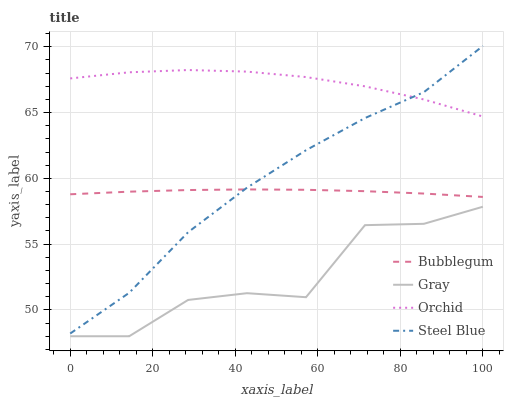Does Gray have the minimum area under the curve?
Answer yes or no. Yes. Does Orchid have the maximum area under the curve?
Answer yes or no. Yes. Does Steel Blue have the minimum area under the curve?
Answer yes or no. No. Does Steel Blue have the maximum area under the curve?
Answer yes or no. No. Is Bubblegum the smoothest?
Answer yes or no. Yes. Is Gray the roughest?
Answer yes or no. Yes. Is Steel Blue the smoothest?
Answer yes or no. No. Is Steel Blue the roughest?
Answer yes or no. No. Does Gray have the lowest value?
Answer yes or no. Yes. Does Steel Blue have the lowest value?
Answer yes or no. No. Does Steel Blue have the highest value?
Answer yes or no. Yes. Does Bubblegum have the highest value?
Answer yes or no. No. Is Gray less than Steel Blue?
Answer yes or no. Yes. Is Orchid greater than Bubblegum?
Answer yes or no. Yes. Does Bubblegum intersect Steel Blue?
Answer yes or no. Yes. Is Bubblegum less than Steel Blue?
Answer yes or no. No. Is Bubblegum greater than Steel Blue?
Answer yes or no. No. Does Gray intersect Steel Blue?
Answer yes or no. No. 